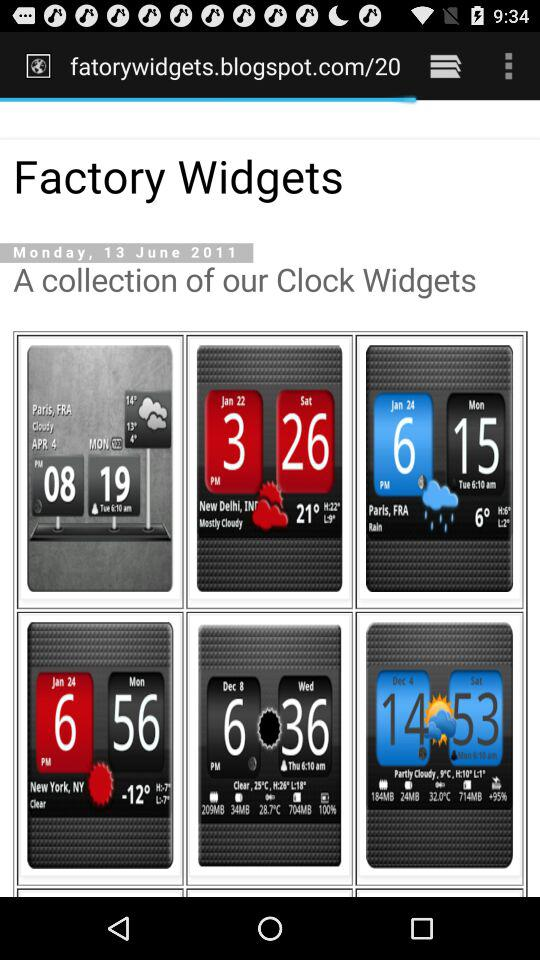What is the date and day? The date is June 13, 2011 and the day is Monday. 